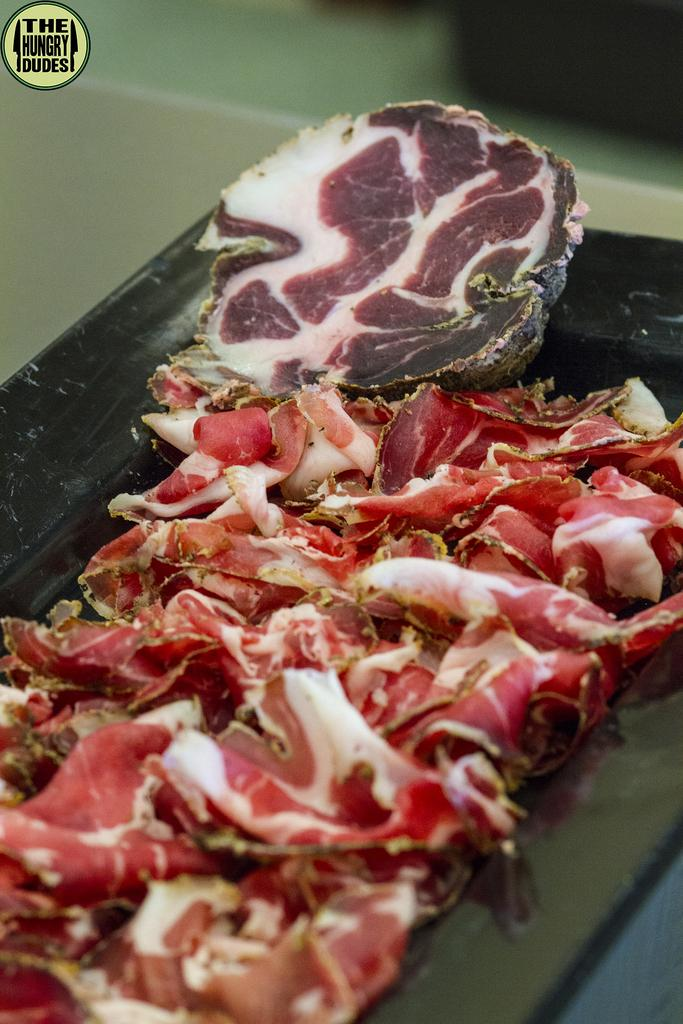What type of food is visible in the image? There is red meat in the image. How is the red meat arranged or contained in the image? The red meat is in a tray. Where is the tray with the red meat located? The tray is on a table. What type of flower is growing in the jar on the table in the image? There is no flower or jar present in the image; it only features red meat in a tray on a table. 